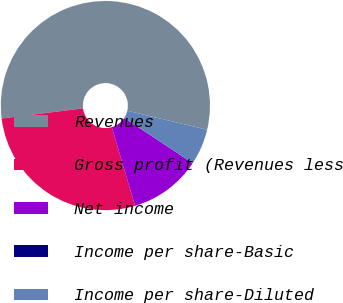<chart> <loc_0><loc_0><loc_500><loc_500><pie_chart><fcel>Revenues<fcel>Gross profit (Revenues less<fcel>Net income<fcel>Income per share-Basic<fcel>Income per share-Diluted<nl><fcel>55.68%<fcel>27.61%<fcel>11.14%<fcel>0.0%<fcel>5.57%<nl></chart> 